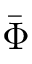Convert formula to latex. <formula><loc_0><loc_0><loc_500><loc_500>\bar { \Phi }</formula> 